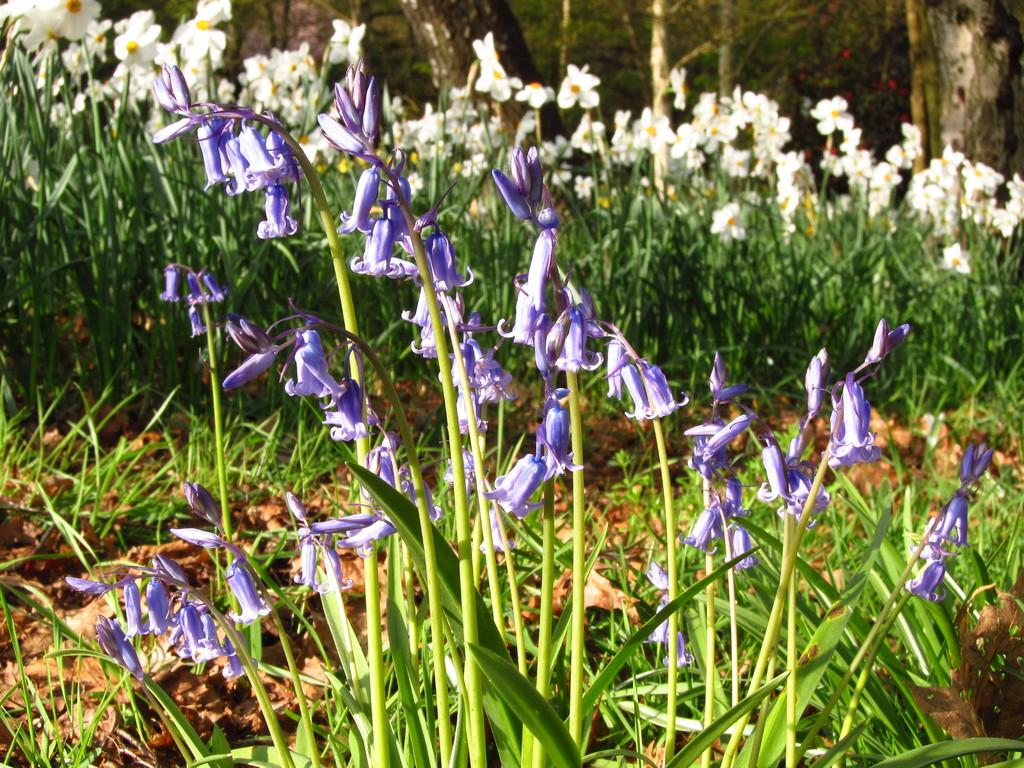What types of vegetation can be seen in the image? There are plants and flowers in the image. Can you describe the background of the image? There are trees in the background of the image. What type of nail is being used to hold the cheese in the image? There is no nail or cheese present in the image; it features plants and flowers. 